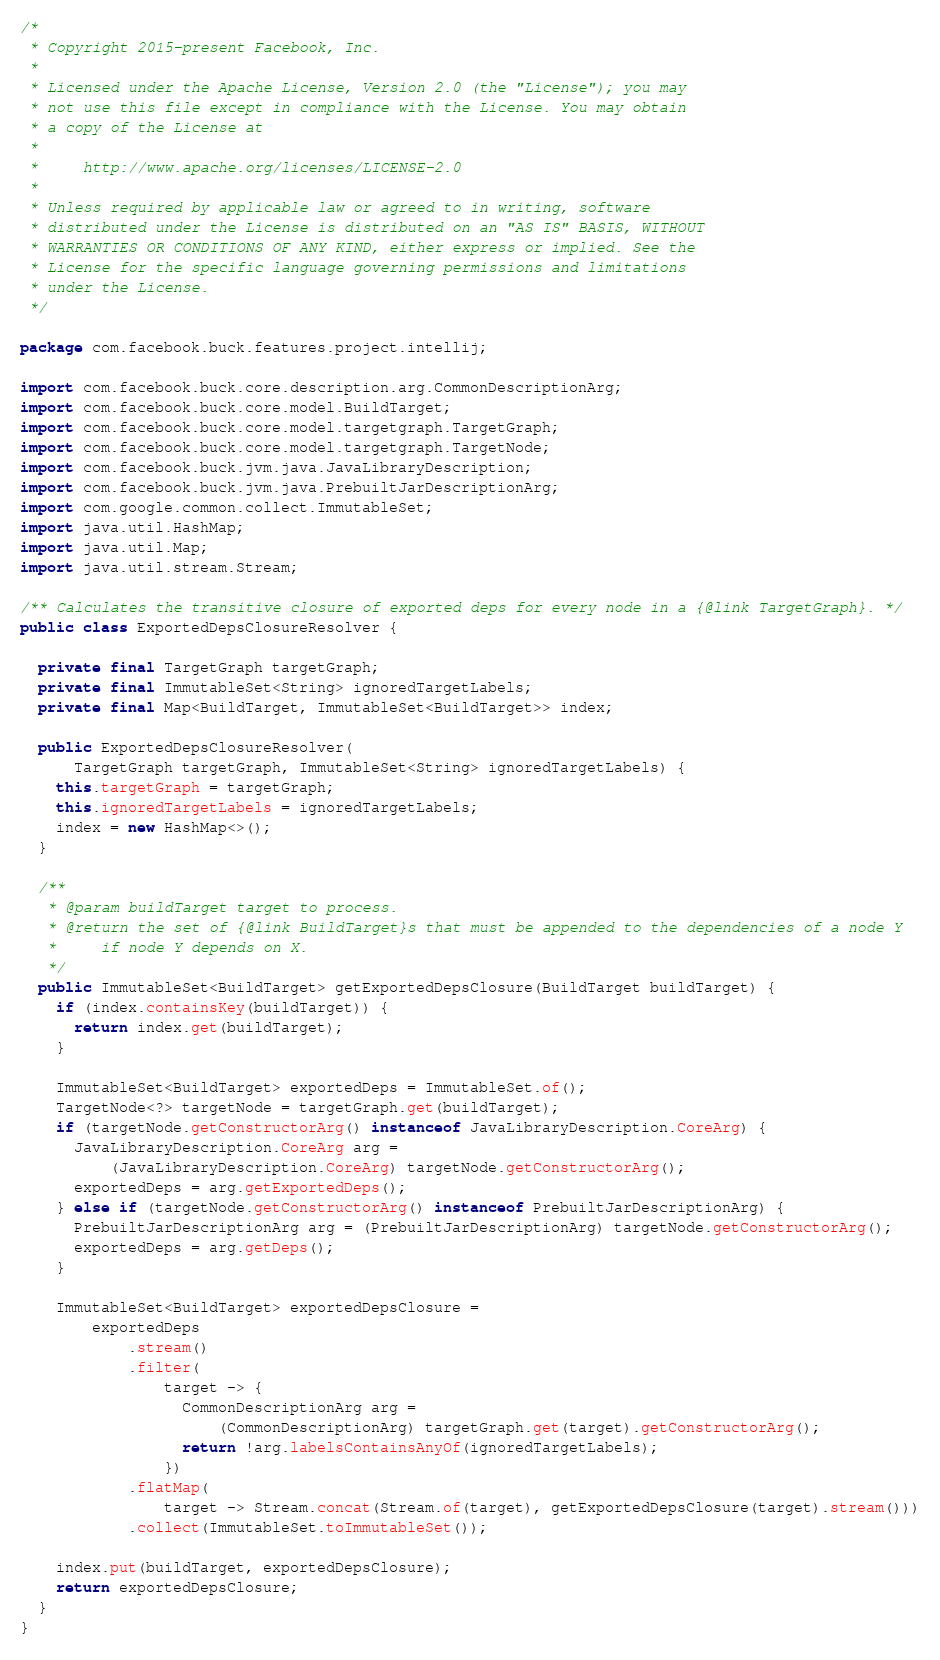Convert code to text. <code><loc_0><loc_0><loc_500><loc_500><_Java_>/*
 * Copyright 2015-present Facebook, Inc.
 *
 * Licensed under the Apache License, Version 2.0 (the "License"); you may
 * not use this file except in compliance with the License. You may obtain
 * a copy of the License at
 *
 *     http://www.apache.org/licenses/LICENSE-2.0
 *
 * Unless required by applicable law or agreed to in writing, software
 * distributed under the License is distributed on an "AS IS" BASIS, WITHOUT
 * WARRANTIES OR CONDITIONS OF ANY KIND, either express or implied. See the
 * License for the specific language governing permissions and limitations
 * under the License.
 */

package com.facebook.buck.features.project.intellij;

import com.facebook.buck.core.description.arg.CommonDescriptionArg;
import com.facebook.buck.core.model.BuildTarget;
import com.facebook.buck.core.model.targetgraph.TargetGraph;
import com.facebook.buck.core.model.targetgraph.TargetNode;
import com.facebook.buck.jvm.java.JavaLibraryDescription;
import com.facebook.buck.jvm.java.PrebuiltJarDescriptionArg;
import com.google.common.collect.ImmutableSet;
import java.util.HashMap;
import java.util.Map;
import java.util.stream.Stream;

/** Calculates the transitive closure of exported deps for every node in a {@link TargetGraph}. */
public class ExportedDepsClosureResolver {

  private final TargetGraph targetGraph;
  private final ImmutableSet<String> ignoredTargetLabels;
  private final Map<BuildTarget, ImmutableSet<BuildTarget>> index;

  public ExportedDepsClosureResolver(
      TargetGraph targetGraph, ImmutableSet<String> ignoredTargetLabels) {
    this.targetGraph = targetGraph;
    this.ignoredTargetLabels = ignoredTargetLabels;
    index = new HashMap<>();
  }

  /**
   * @param buildTarget target to process.
   * @return the set of {@link BuildTarget}s that must be appended to the dependencies of a node Y
   *     if node Y depends on X.
   */
  public ImmutableSet<BuildTarget> getExportedDepsClosure(BuildTarget buildTarget) {
    if (index.containsKey(buildTarget)) {
      return index.get(buildTarget);
    }

    ImmutableSet<BuildTarget> exportedDeps = ImmutableSet.of();
    TargetNode<?> targetNode = targetGraph.get(buildTarget);
    if (targetNode.getConstructorArg() instanceof JavaLibraryDescription.CoreArg) {
      JavaLibraryDescription.CoreArg arg =
          (JavaLibraryDescription.CoreArg) targetNode.getConstructorArg();
      exportedDeps = arg.getExportedDeps();
    } else if (targetNode.getConstructorArg() instanceof PrebuiltJarDescriptionArg) {
      PrebuiltJarDescriptionArg arg = (PrebuiltJarDescriptionArg) targetNode.getConstructorArg();
      exportedDeps = arg.getDeps();
    }

    ImmutableSet<BuildTarget> exportedDepsClosure =
        exportedDeps
            .stream()
            .filter(
                target -> {
                  CommonDescriptionArg arg =
                      (CommonDescriptionArg) targetGraph.get(target).getConstructorArg();
                  return !arg.labelsContainsAnyOf(ignoredTargetLabels);
                })
            .flatMap(
                target -> Stream.concat(Stream.of(target), getExportedDepsClosure(target).stream()))
            .collect(ImmutableSet.toImmutableSet());

    index.put(buildTarget, exportedDepsClosure);
    return exportedDepsClosure;
  }
}
</code> 